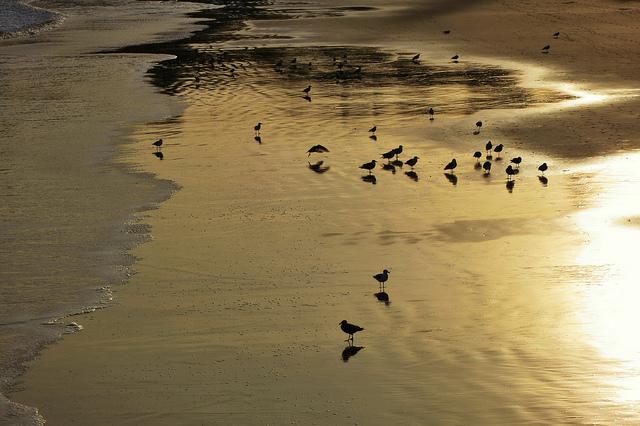What are the birds doing?
Keep it brief. Standing. Are the birds going to sleep?
Quick response, please. No. Is the photographer more than 100 ft above the water?
Short answer required. No. What type of bird?
Quick response, please. Seagull. Is part of this water frozen?
Concise answer only. No. How many birds are walking on the sand?
Concise answer only. 30. 